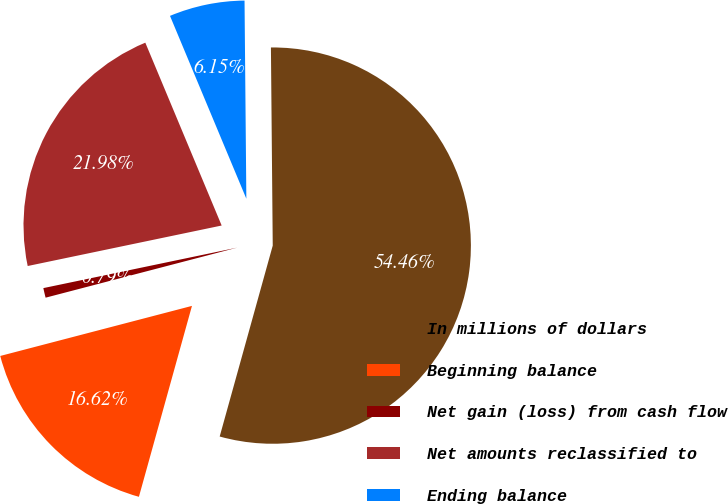<chart> <loc_0><loc_0><loc_500><loc_500><pie_chart><fcel>In millions of dollars<fcel>Beginning balance<fcel>Net gain (loss) from cash flow<fcel>Net amounts reclassified to<fcel>Ending balance<nl><fcel>54.46%<fcel>16.62%<fcel>0.79%<fcel>21.98%<fcel>6.15%<nl></chart> 